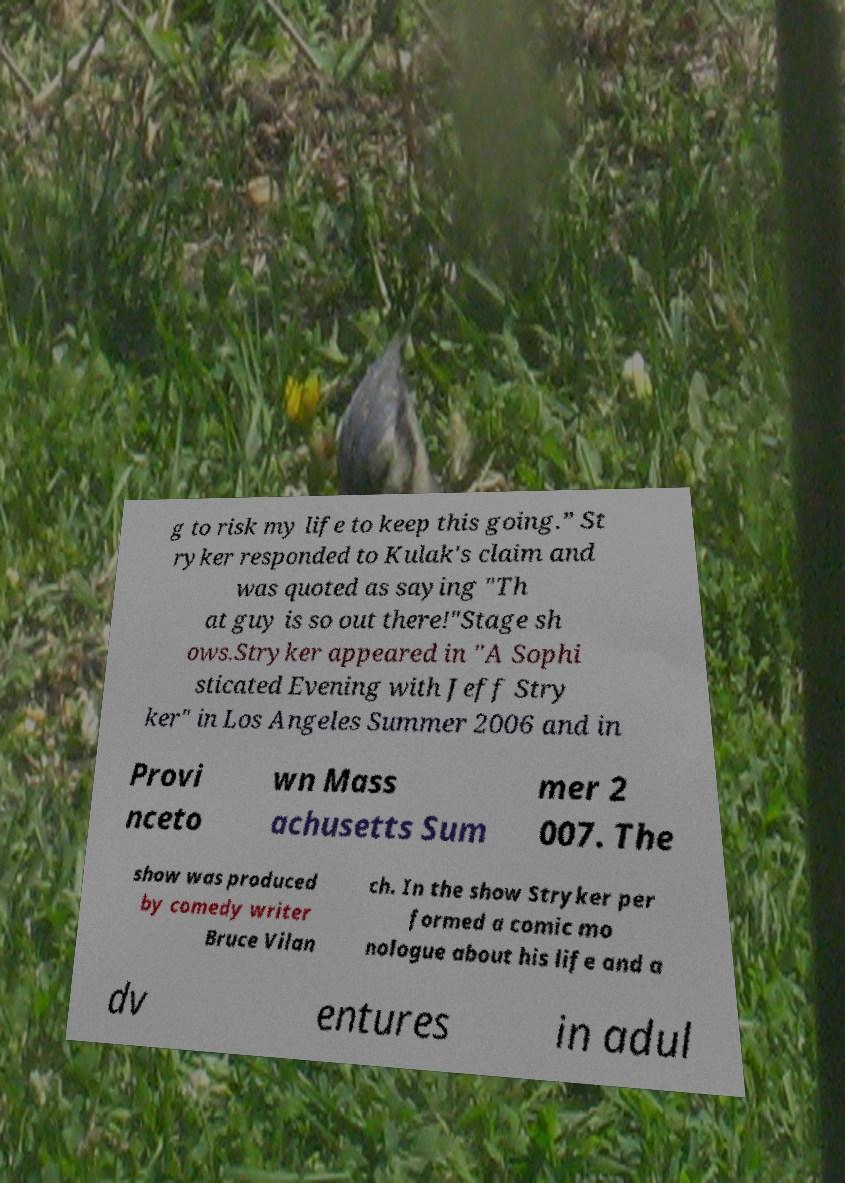Please read and relay the text visible in this image. What does it say? g to risk my life to keep this going.” St ryker responded to Kulak's claim and was quoted as saying "Th at guy is so out there!"Stage sh ows.Stryker appeared in "A Sophi sticated Evening with Jeff Stry ker" in Los Angeles Summer 2006 and in Provi nceto wn Mass achusetts Sum mer 2 007. The show was produced by comedy writer Bruce Vilan ch. In the show Stryker per formed a comic mo nologue about his life and a dv entures in adul 